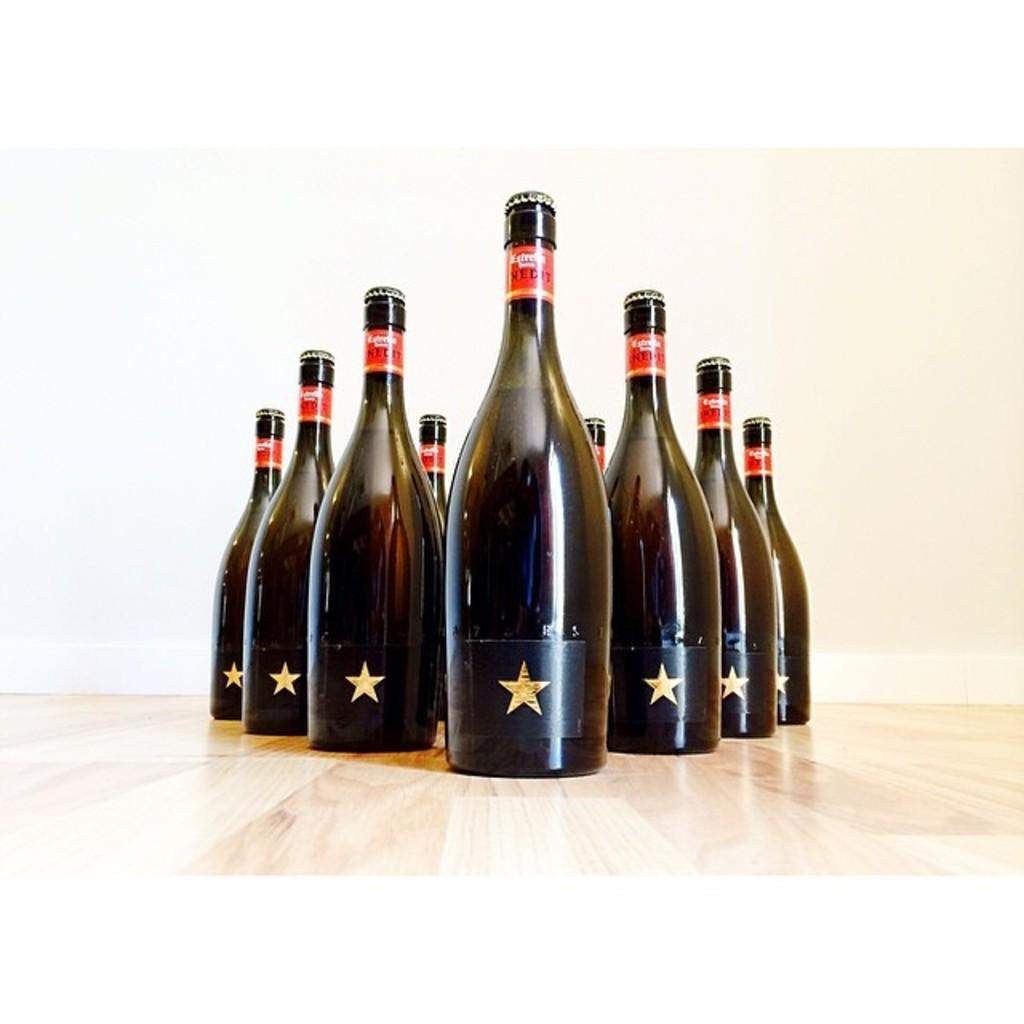What objects are present in the image? There are bottles in the image. How are the bottles arranged? The bottles are arranged in a design format. Where are the bottles located? The bottles are on a table. What type of oil is being used to create the design with the bottles? There is no oil present in the image, and the bottles are not being used to create a design with oil. 